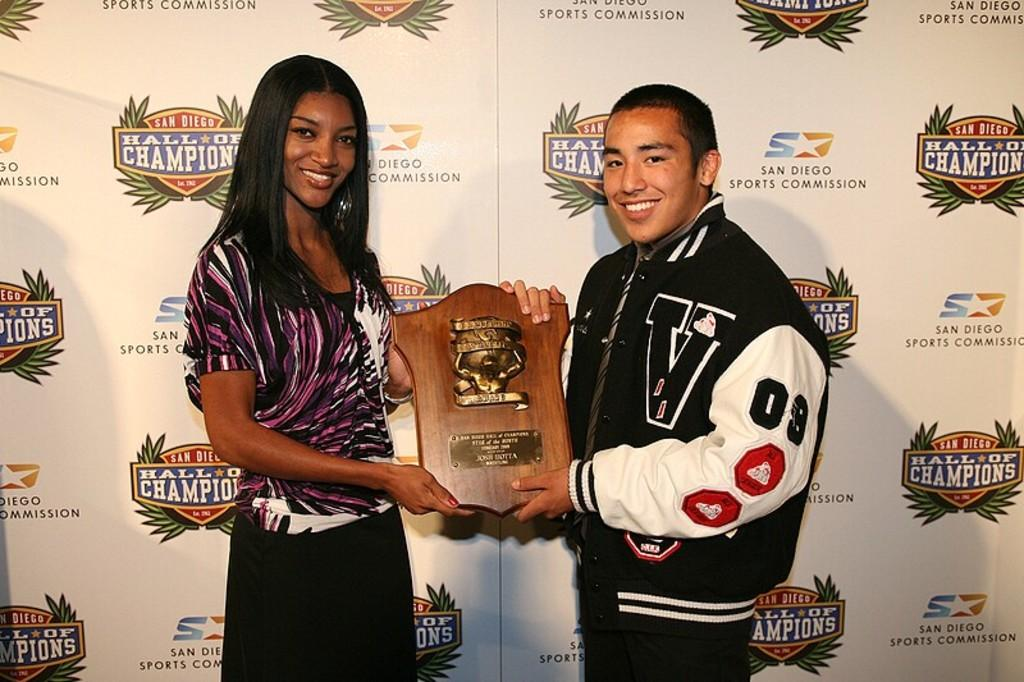<image>
Share a concise interpretation of the image provided. A man and a woman holding a plaque together with the man wearing a jacket with the letter V on it 